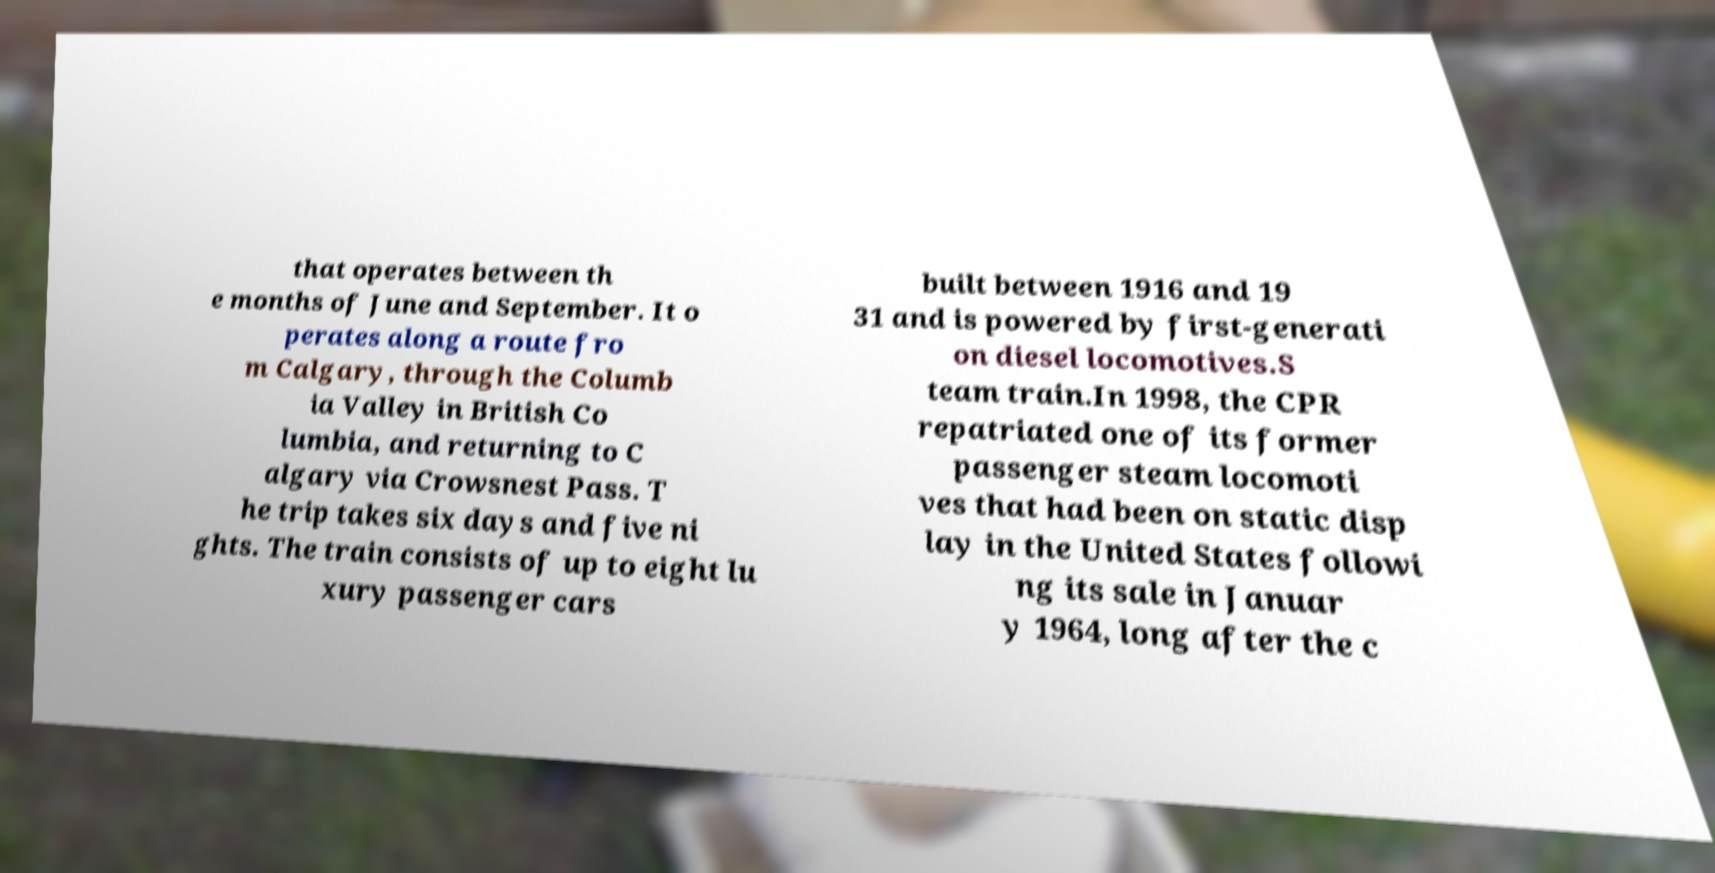There's text embedded in this image that I need extracted. Can you transcribe it verbatim? that operates between th e months of June and September. It o perates along a route fro m Calgary, through the Columb ia Valley in British Co lumbia, and returning to C algary via Crowsnest Pass. T he trip takes six days and five ni ghts. The train consists of up to eight lu xury passenger cars built between 1916 and 19 31 and is powered by first-generati on diesel locomotives.S team train.In 1998, the CPR repatriated one of its former passenger steam locomoti ves that had been on static disp lay in the United States followi ng its sale in Januar y 1964, long after the c 